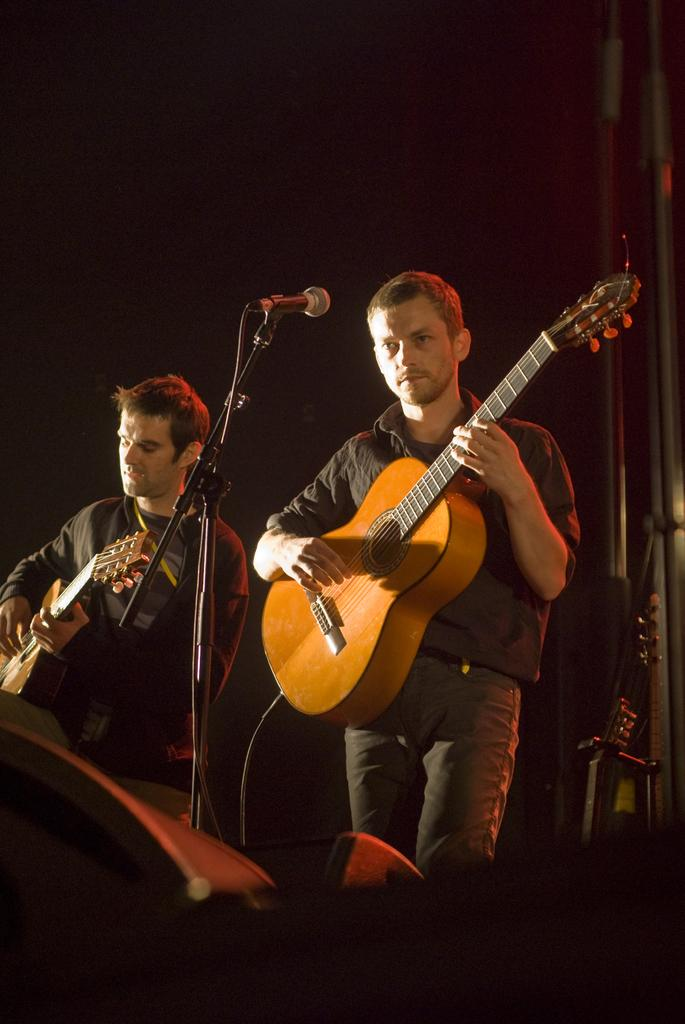How many people are in the image? There are two persons in the image. What are the persons doing in the image? The persons are standing and playing guitar. What object related to sound can be seen in the image? There is a microphone stand in the image. How many dogs are sitting near the hydrant in the image? There are no dogs or hydrants present in the image. 